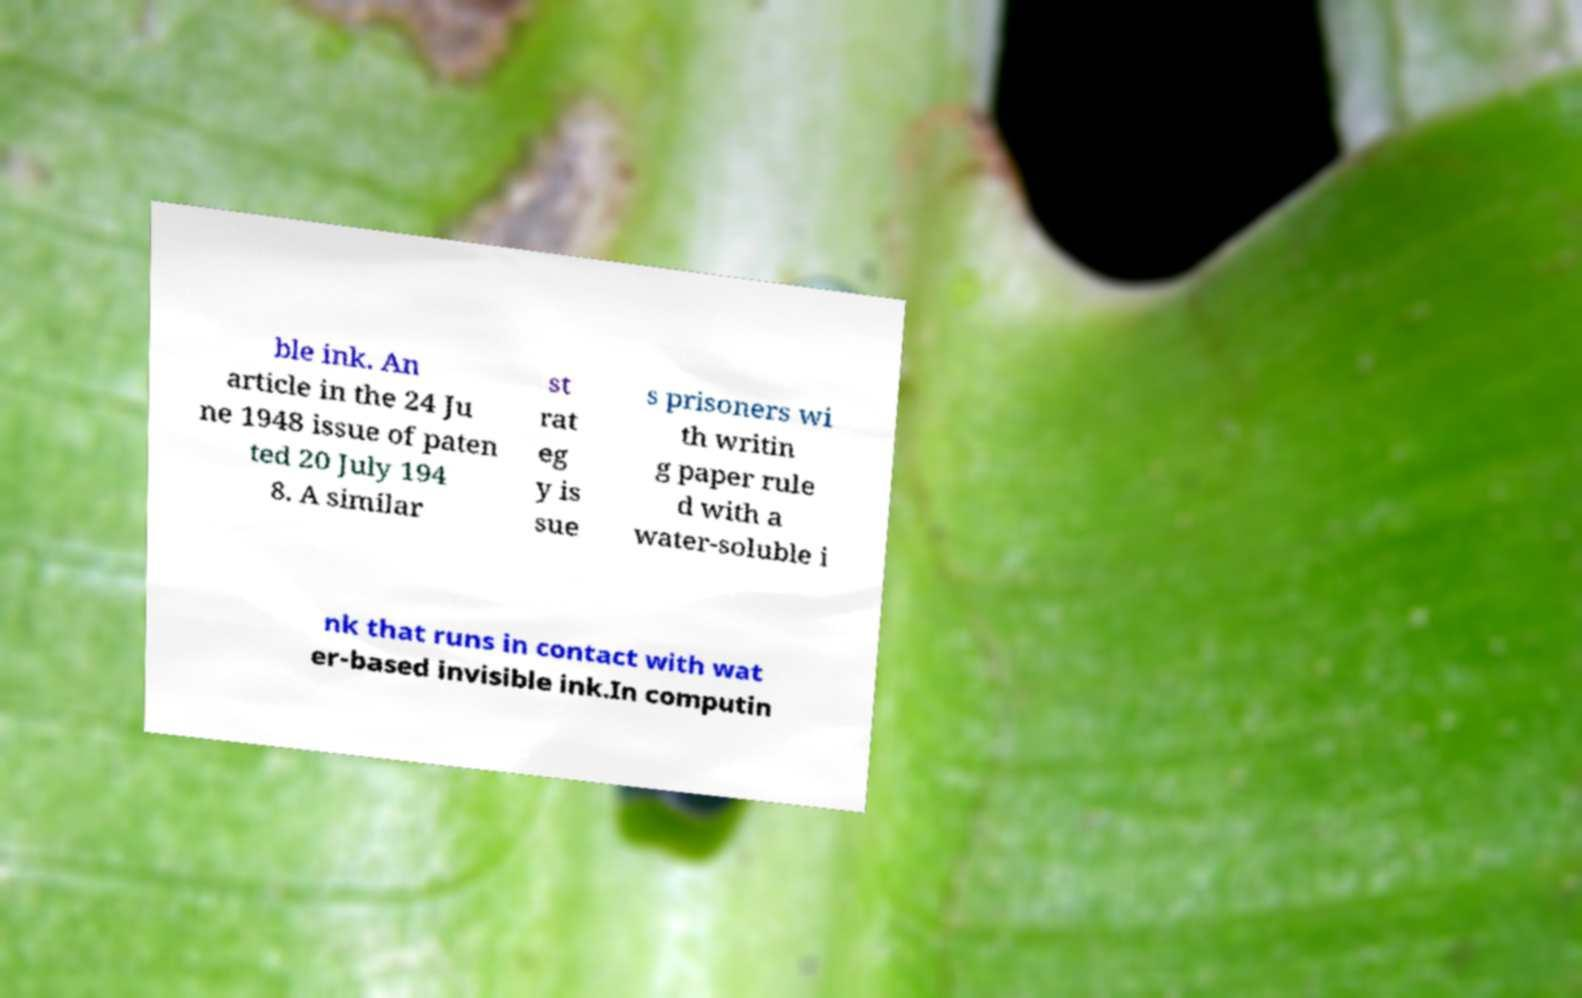Please read and relay the text visible in this image. What does it say? ble ink. An article in the 24 Ju ne 1948 issue of paten ted 20 July 194 8. A similar st rat eg y is sue s prisoners wi th writin g paper rule d with a water-soluble i nk that runs in contact with wat er-based invisible ink.In computin 